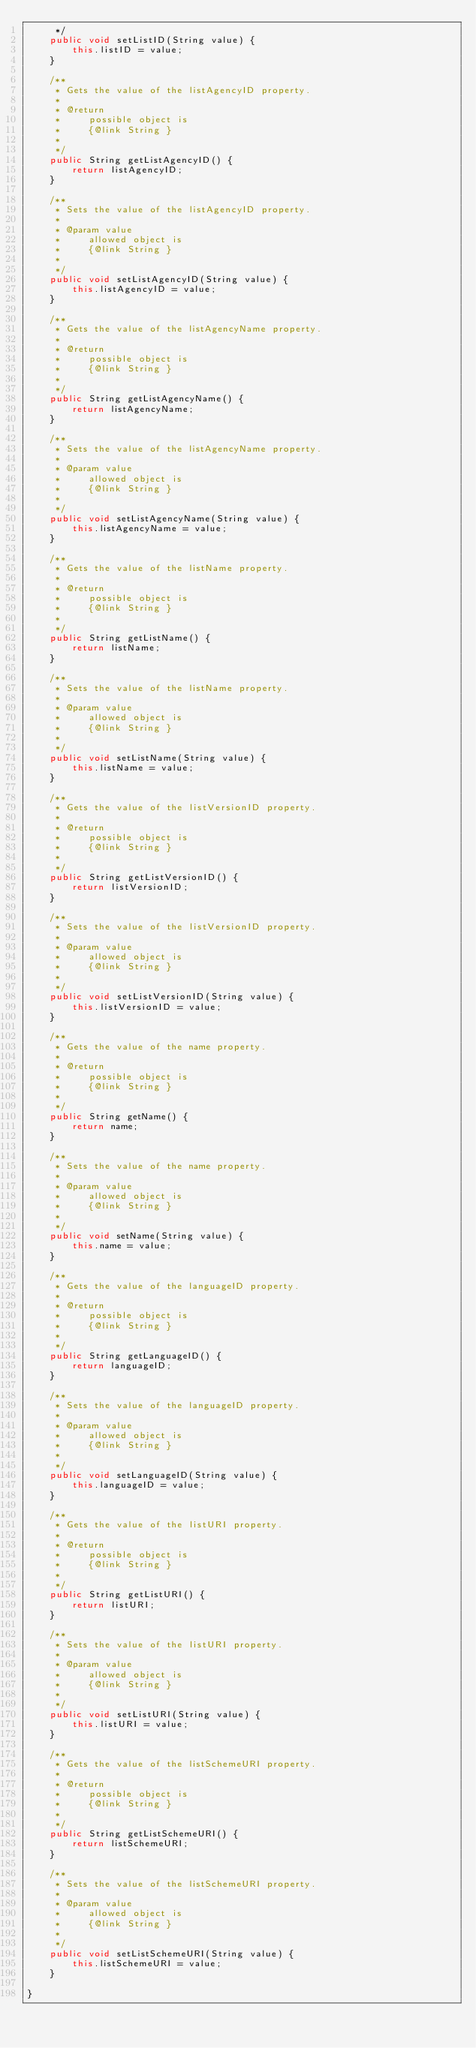Convert code to text. <code><loc_0><loc_0><loc_500><loc_500><_Java_>     */
    public void setListID(String value) {
        this.listID = value;
    }

    /**
     * Gets the value of the listAgencyID property.
     * 
     * @return
     *     possible object is
     *     {@link String }
     *     
     */
    public String getListAgencyID() {
        return listAgencyID;
    }

    /**
     * Sets the value of the listAgencyID property.
     * 
     * @param value
     *     allowed object is
     *     {@link String }
     *     
     */
    public void setListAgencyID(String value) {
        this.listAgencyID = value;
    }

    /**
     * Gets the value of the listAgencyName property.
     * 
     * @return
     *     possible object is
     *     {@link String }
     *     
     */
    public String getListAgencyName() {
        return listAgencyName;
    }

    /**
     * Sets the value of the listAgencyName property.
     * 
     * @param value
     *     allowed object is
     *     {@link String }
     *     
     */
    public void setListAgencyName(String value) {
        this.listAgencyName = value;
    }

    /**
     * Gets the value of the listName property.
     * 
     * @return
     *     possible object is
     *     {@link String }
     *     
     */
    public String getListName() {
        return listName;
    }

    /**
     * Sets the value of the listName property.
     * 
     * @param value
     *     allowed object is
     *     {@link String }
     *     
     */
    public void setListName(String value) {
        this.listName = value;
    }

    /**
     * Gets the value of the listVersionID property.
     * 
     * @return
     *     possible object is
     *     {@link String }
     *     
     */
    public String getListVersionID() {
        return listVersionID;
    }

    /**
     * Sets the value of the listVersionID property.
     * 
     * @param value
     *     allowed object is
     *     {@link String }
     *     
     */
    public void setListVersionID(String value) {
        this.listVersionID = value;
    }

    /**
     * Gets the value of the name property.
     * 
     * @return
     *     possible object is
     *     {@link String }
     *     
     */
    public String getName() {
        return name;
    }

    /**
     * Sets the value of the name property.
     * 
     * @param value
     *     allowed object is
     *     {@link String }
     *     
     */
    public void setName(String value) {
        this.name = value;
    }

    /**
     * Gets the value of the languageID property.
     * 
     * @return
     *     possible object is
     *     {@link String }
     *     
     */
    public String getLanguageID() {
        return languageID;
    }

    /**
     * Sets the value of the languageID property.
     * 
     * @param value
     *     allowed object is
     *     {@link String }
     *     
     */
    public void setLanguageID(String value) {
        this.languageID = value;
    }

    /**
     * Gets the value of the listURI property.
     * 
     * @return
     *     possible object is
     *     {@link String }
     *     
     */
    public String getListURI() {
        return listURI;
    }

    /**
     * Sets the value of the listURI property.
     * 
     * @param value
     *     allowed object is
     *     {@link String }
     *     
     */
    public void setListURI(String value) {
        this.listURI = value;
    }

    /**
     * Gets the value of the listSchemeURI property.
     * 
     * @return
     *     possible object is
     *     {@link String }
     *     
     */
    public String getListSchemeURI() {
        return listSchemeURI;
    }

    /**
     * Sets the value of the listSchemeURI property.
     * 
     * @param value
     *     allowed object is
     *     {@link String }
     *     
     */
    public void setListSchemeURI(String value) {
        this.listSchemeURI = value;
    }

}
</code> 